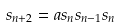<formula> <loc_0><loc_0><loc_500><loc_500>s _ { n + 2 } = a s _ { n } s _ { n - 1 } s _ { n }</formula> 